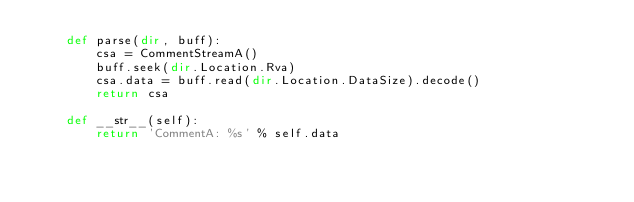<code> <loc_0><loc_0><loc_500><loc_500><_Python_>	def parse(dir, buff):
		csa = CommentStreamA()
		buff.seek(dir.Location.Rva)
		csa.data = buff.read(dir.Location.DataSize).decode()
		return csa
	
	def __str__(self):
		return 'CommentA: %s' % self.data</code> 